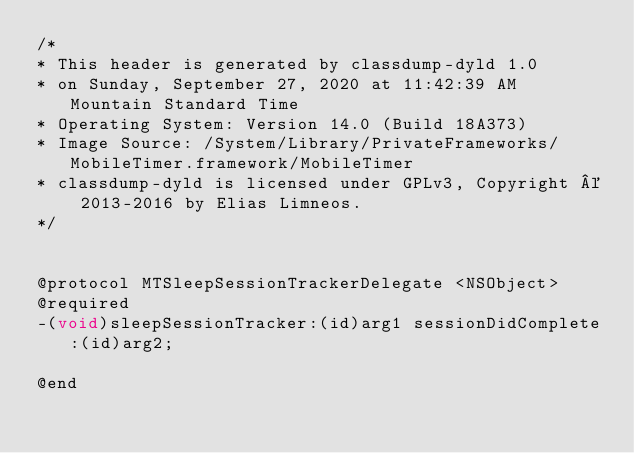Convert code to text. <code><loc_0><loc_0><loc_500><loc_500><_C_>/*
* This header is generated by classdump-dyld 1.0
* on Sunday, September 27, 2020 at 11:42:39 AM Mountain Standard Time
* Operating System: Version 14.0 (Build 18A373)
* Image Source: /System/Library/PrivateFrameworks/MobileTimer.framework/MobileTimer
* classdump-dyld is licensed under GPLv3, Copyright © 2013-2016 by Elias Limneos.
*/


@protocol MTSleepSessionTrackerDelegate <NSObject>
@required
-(void)sleepSessionTracker:(id)arg1 sessionDidComplete:(id)arg2;

@end

</code> 